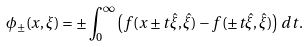Convert formula to latex. <formula><loc_0><loc_0><loc_500><loc_500>\phi _ { \pm } ( x , \xi ) = \pm \int _ { 0 } ^ { \infty } \left ( f ( x \pm t \hat { \xi } , \hat { \xi } ) - f ( \pm t \hat { \xi } , \hat { \xi } ) \right ) \, d t .</formula> 